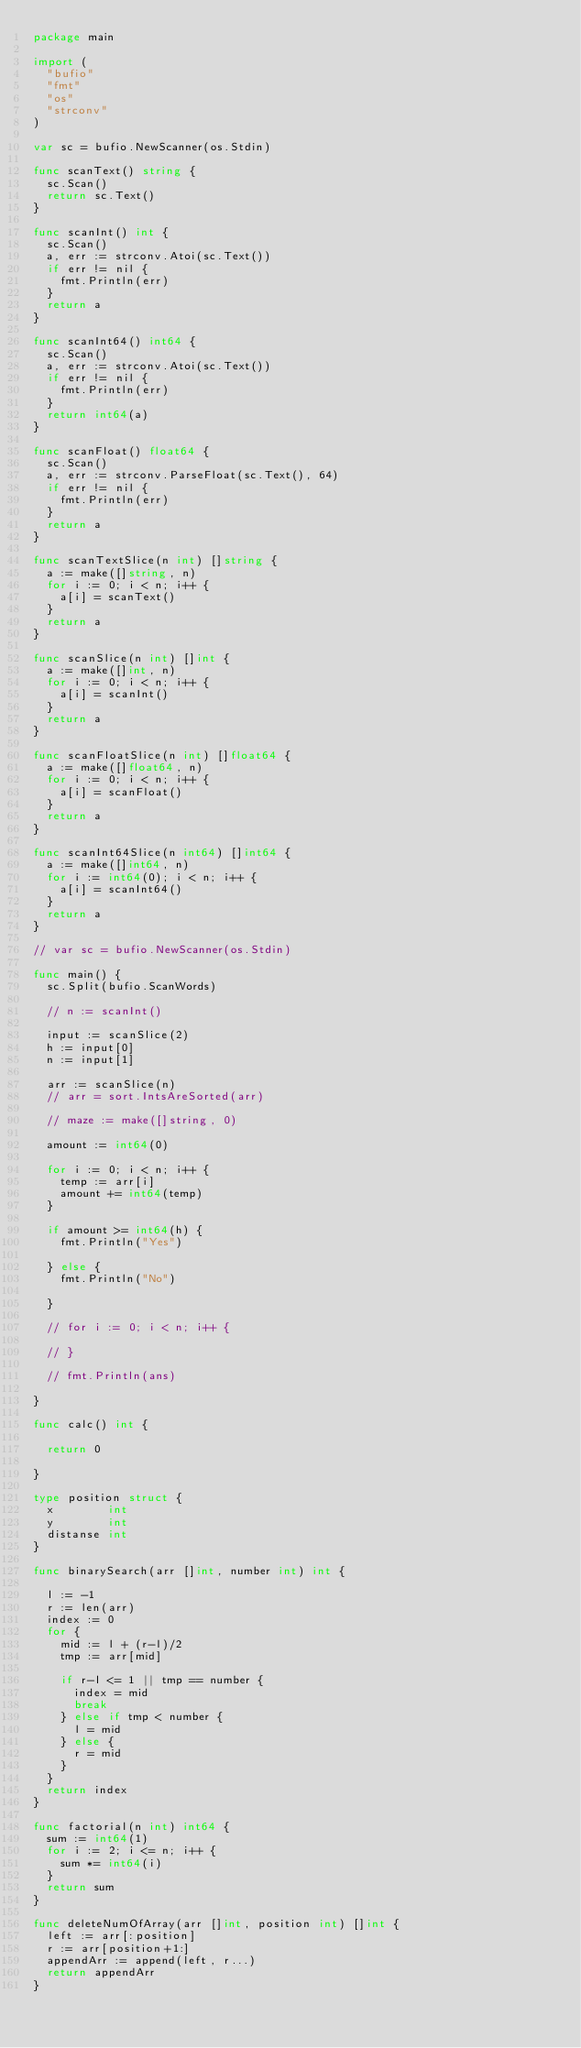<code> <loc_0><loc_0><loc_500><loc_500><_Go_>package main

import (
	"bufio"
	"fmt"
	"os"
	"strconv"
)

var sc = bufio.NewScanner(os.Stdin)

func scanText() string {
	sc.Scan()
	return sc.Text()
}

func scanInt() int {
	sc.Scan()
	a, err := strconv.Atoi(sc.Text())
	if err != nil {
		fmt.Println(err)
	}
	return a
}

func scanInt64() int64 {
	sc.Scan()
	a, err := strconv.Atoi(sc.Text())
	if err != nil {
		fmt.Println(err)
	}
	return int64(a)
}

func scanFloat() float64 {
	sc.Scan()
	a, err := strconv.ParseFloat(sc.Text(), 64)
	if err != nil {
		fmt.Println(err)
	}
	return a
}

func scanTextSlice(n int) []string {
	a := make([]string, n)
	for i := 0; i < n; i++ {
		a[i] = scanText()
	}
	return a
}

func scanSlice(n int) []int {
	a := make([]int, n)
	for i := 0; i < n; i++ {
		a[i] = scanInt()
	}
	return a
}

func scanFloatSlice(n int) []float64 {
	a := make([]float64, n)
	for i := 0; i < n; i++ {
		a[i] = scanFloat()
	}
	return a
}

func scanInt64Slice(n int64) []int64 {
	a := make([]int64, n)
	for i := int64(0); i < n; i++ {
		a[i] = scanInt64()
	}
	return a
}

// var sc = bufio.NewScanner(os.Stdin)

func main() {
	sc.Split(bufio.ScanWords)

	// n := scanInt()

	input := scanSlice(2)
	h := input[0]
	n := input[1]

	arr := scanSlice(n)
	// arr = sort.IntsAreSorted(arr)

	// maze := make([]string, 0)

	amount := int64(0)

	for i := 0; i < n; i++ {
		temp := arr[i]
		amount += int64(temp)
	}

	if amount >= int64(h) {
		fmt.Println("Yes")

	} else {
		fmt.Println("No")

	}

	// for i := 0; i < n; i++ {

	// }

	// fmt.Println(ans)

}

func calc() int {

	return 0

}

type position struct {
	x        int
	y        int
	distanse int
}

func binarySearch(arr []int, number int) int {

	l := -1
	r := len(arr)
	index := 0
	for {
		mid := l + (r-l)/2
		tmp := arr[mid]

		if r-l <= 1 || tmp == number {
			index = mid
			break
		} else if tmp < number {
			l = mid
		} else {
			r = mid
		}
	}
	return index
}

func factorial(n int) int64 {
	sum := int64(1)
	for i := 2; i <= n; i++ {
		sum *= int64(i)
	}
	return sum
}

func deleteNumOfArray(arr []int, position int) []int {
	left := arr[:position]
	r := arr[position+1:]
	appendArr := append(left, r...)
	return appendArr
}
</code> 